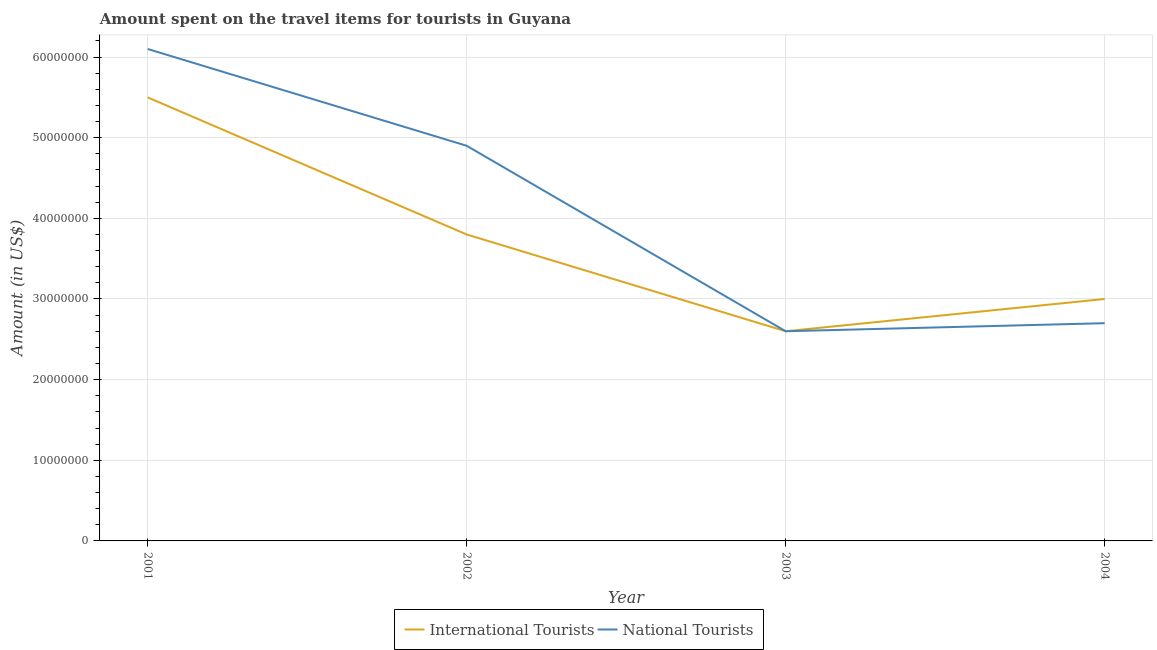Does the line corresponding to amount spent on travel items of international tourists intersect with the line corresponding to amount spent on travel items of national tourists?
Offer a terse response. Yes. Is the number of lines equal to the number of legend labels?
Provide a short and direct response. Yes. What is the amount spent on travel items of national tourists in 2004?
Provide a short and direct response. 2.70e+07. Across all years, what is the maximum amount spent on travel items of national tourists?
Keep it short and to the point. 6.10e+07. Across all years, what is the minimum amount spent on travel items of international tourists?
Offer a terse response. 2.60e+07. In which year was the amount spent on travel items of national tourists maximum?
Offer a very short reply. 2001. What is the total amount spent on travel items of national tourists in the graph?
Provide a succinct answer. 1.63e+08. What is the difference between the amount spent on travel items of international tourists in 2001 and that in 2003?
Keep it short and to the point. 2.90e+07. What is the difference between the amount spent on travel items of national tourists in 2003 and the amount spent on travel items of international tourists in 2004?
Provide a succinct answer. -4.00e+06. What is the average amount spent on travel items of national tourists per year?
Your answer should be compact. 4.08e+07. In the year 2004, what is the difference between the amount spent on travel items of national tourists and amount spent on travel items of international tourists?
Your answer should be compact. -3.00e+06. What is the ratio of the amount spent on travel items of international tourists in 2001 to that in 2002?
Your answer should be compact. 1.45. Is the amount spent on travel items of international tourists in 2002 less than that in 2004?
Make the answer very short. No. What is the difference between the highest and the second highest amount spent on travel items of international tourists?
Provide a succinct answer. 1.70e+07. What is the difference between the highest and the lowest amount spent on travel items of international tourists?
Give a very brief answer. 2.90e+07. In how many years, is the amount spent on travel items of international tourists greater than the average amount spent on travel items of international tourists taken over all years?
Make the answer very short. 2. Is the sum of the amount spent on travel items of international tourists in 2001 and 2002 greater than the maximum amount spent on travel items of national tourists across all years?
Provide a succinct answer. Yes. Is the amount spent on travel items of national tourists strictly less than the amount spent on travel items of international tourists over the years?
Your answer should be very brief. No. How many years are there in the graph?
Your answer should be very brief. 4. What is the difference between two consecutive major ticks on the Y-axis?
Offer a terse response. 1.00e+07. Does the graph contain grids?
Your response must be concise. Yes. Where does the legend appear in the graph?
Offer a very short reply. Bottom center. How are the legend labels stacked?
Provide a short and direct response. Horizontal. What is the title of the graph?
Your answer should be compact. Amount spent on the travel items for tourists in Guyana. Does "Female population" appear as one of the legend labels in the graph?
Your answer should be compact. No. What is the label or title of the Y-axis?
Make the answer very short. Amount (in US$). What is the Amount (in US$) of International Tourists in 2001?
Give a very brief answer. 5.50e+07. What is the Amount (in US$) in National Tourists in 2001?
Your answer should be compact. 6.10e+07. What is the Amount (in US$) of International Tourists in 2002?
Keep it short and to the point. 3.80e+07. What is the Amount (in US$) in National Tourists in 2002?
Provide a succinct answer. 4.90e+07. What is the Amount (in US$) of International Tourists in 2003?
Your answer should be very brief. 2.60e+07. What is the Amount (in US$) of National Tourists in 2003?
Give a very brief answer. 2.60e+07. What is the Amount (in US$) of International Tourists in 2004?
Ensure brevity in your answer.  3.00e+07. What is the Amount (in US$) of National Tourists in 2004?
Your response must be concise. 2.70e+07. Across all years, what is the maximum Amount (in US$) of International Tourists?
Offer a terse response. 5.50e+07. Across all years, what is the maximum Amount (in US$) of National Tourists?
Keep it short and to the point. 6.10e+07. Across all years, what is the minimum Amount (in US$) of International Tourists?
Keep it short and to the point. 2.60e+07. Across all years, what is the minimum Amount (in US$) of National Tourists?
Ensure brevity in your answer.  2.60e+07. What is the total Amount (in US$) of International Tourists in the graph?
Provide a short and direct response. 1.49e+08. What is the total Amount (in US$) of National Tourists in the graph?
Offer a terse response. 1.63e+08. What is the difference between the Amount (in US$) of International Tourists in 2001 and that in 2002?
Make the answer very short. 1.70e+07. What is the difference between the Amount (in US$) of International Tourists in 2001 and that in 2003?
Make the answer very short. 2.90e+07. What is the difference between the Amount (in US$) of National Tourists in 2001 and that in 2003?
Make the answer very short. 3.50e+07. What is the difference between the Amount (in US$) in International Tourists in 2001 and that in 2004?
Your answer should be compact. 2.50e+07. What is the difference between the Amount (in US$) of National Tourists in 2001 and that in 2004?
Your answer should be compact. 3.40e+07. What is the difference between the Amount (in US$) in International Tourists in 2002 and that in 2003?
Give a very brief answer. 1.20e+07. What is the difference between the Amount (in US$) in National Tourists in 2002 and that in 2003?
Offer a terse response. 2.30e+07. What is the difference between the Amount (in US$) of National Tourists in 2002 and that in 2004?
Provide a short and direct response. 2.20e+07. What is the difference between the Amount (in US$) of International Tourists in 2003 and that in 2004?
Offer a very short reply. -4.00e+06. What is the difference between the Amount (in US$) of International Tourists in 2001 and the Amount (in US$) of National Tourists in 2002?
Provide a succinct answer. 6.00e+06. What is the difference between the Amount (in US$) of International Tourists in 2001 and the Amount (in US$) of National Tourists in 2003?
Offer a terse response. 2.90e+07. What is the difference between the Amount (in US$) in International Tourists in 2001 and the Amount (in US$) in National Tourists in 2004?
Provide a succinct answer. 2.80e+07. What is the difference between the Amount (in US$) of International Tourists in 2002 and the Amount (in US$) of National Tourists in 2003?
Your answer should be compact. 1.20e+07. What is the difference between the Amount (in US$) of International Tourists in 2002 and the Amount (in US$) of National Tourists in 2004?
Keep it short and to the point. 1.10e+07. What is the average Amount (in US$) in International Tourists per year?
Your response must be concise. 3.72e+07. What is the average Amount (in US$) of National Tourists per year?
Offer a very short reply. 4.08e+07. In the year 2001, what is the difference between the Amount (in US$) in International Tourists and Amount (in US$) in National Tourists?
Offer a terse response. -6.00e+06. In the year 2002, what is the difference between the Amount (in US$) of International Tourists and Amount (in US$) of National Tourists?
Provide a succinct answer. -1.10e+07. What is the ratio of the Amount (in US$) in International Tourists in 2001 to that in 2002?
Your answer should be compact. 1.45. What is the ratio of the Amount (in US$) in National Tourists in 2001 to that in 2002?
Your answer should be very brief. 1.24. What is the ratio of the Amount (in US$) of International Tourists in 2001 to that in 2003?
Give a very brief answer. 2.12. What is the ratio of the Amount (in US$) in National Tourists in 2001 to that in 2003?
Ensure brevity in your answer.  2.35. What is the ratio of the Amount (in US$) in International Tourists in 2001 to that in 2004?
Your answer should be very brief. 1.83. What is the ratio of the Amount (in US$) in National Tourists in 2001 to that in 2004?
Keep it short and to the point. 2.26. What is the ratio of the Amount (in US$) in International Tourists in 2002 to that in 2003?
Offer a very short reply. 1.46. What is the ratio of the Amount (in US$) of National Tourists in 2002 to that in 2003?
Provide a succinct answer. 1.88. What is the ratio of the Amount (in US$) in International Tourists in 2002 to that in 2004?
Your response must be concise. 1.27. What is the ratio of the Amount (in US$) of National Tourists in 2002 to that in 2004?
Provide a short and direct response. 1.81. What is the ratio of the Amount (in US$) in International Tourists in 2003 to that in 2004?
Your response must be concise. 0.87. What is the difference between the highest and the second highest Amount (in US$) of International Tourists?
Offer a terse response. 1.70e+07. What is the difference between the highest and the second highest Amount (in US$) in National Tourists?
Keep it short and to the point. 1.20e+07. What is the difference between the highest and the lowest Amount (in US$) in International Tourists?
Your answer should be compact. 2.90e+07. What is the difference between the highest and the lowest Amount (in US$) in National Tourists?
Your response must be concise. 3.50e+07. 